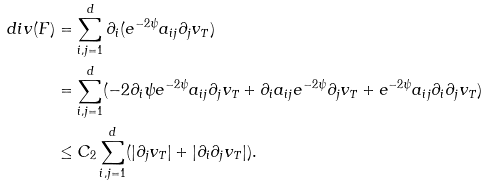<formula> <loc_0><loc_0><loc_500><loc_500>d i v ( F ) & = \sum _ { i , j = 1 } ^ { d } \partial _ { i } ( e ^ { - 2 \psi } a _ { i j } \partial _ { j } v _ { T } ) \\ & = \sum _ { i , j = 1 } ^ { d } ( - 2 \partial _ { i } \psi e ^ { - 2 \psi } a _ { i j } \partial _ { j } v _ { T } + \partial _ { i } a _ { i j } e ^ { - 2 \psi } \partial _ { j } v _ { T } + e ^ { - 2 \psi } a _ { i j } \partial _ { i } \partial _ { j } v _ { T } ) \\ & \leq C _ { 2 } \sum _ { i , j = 1 } ^ { d } ( | \partial _ { j } v _ { T } | + | \partial _ { i } \partial _ { j } v _ { T } | ) .</formula> 